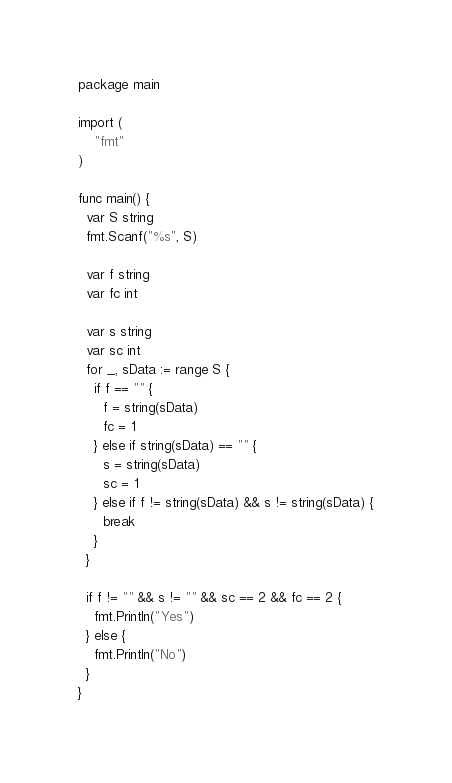<code> <loc_0><loc_0><loc_500><loc_500><_Go_>package main

import (
	"fmt"
)

func main() {
  var S string
  fmt.Scanf("%s", S)

  var f string
  var fc int
  
  var s string
  var sc int
  for _, sData := range S {
    if f == "" {
      f = string(sData)
      fc = 1
    } else if string(sData) == "" {
      s = string(sData)
      sc = 1
    } else if f != string(sData) && s != string(sData) {
      break
    }
  }
  
  if f != "" && s != "" && sc == 2 && fc == 2 {
    fmt.Println("Yes")
  } else {
    fmt.Println("No")
  }
}</code> 